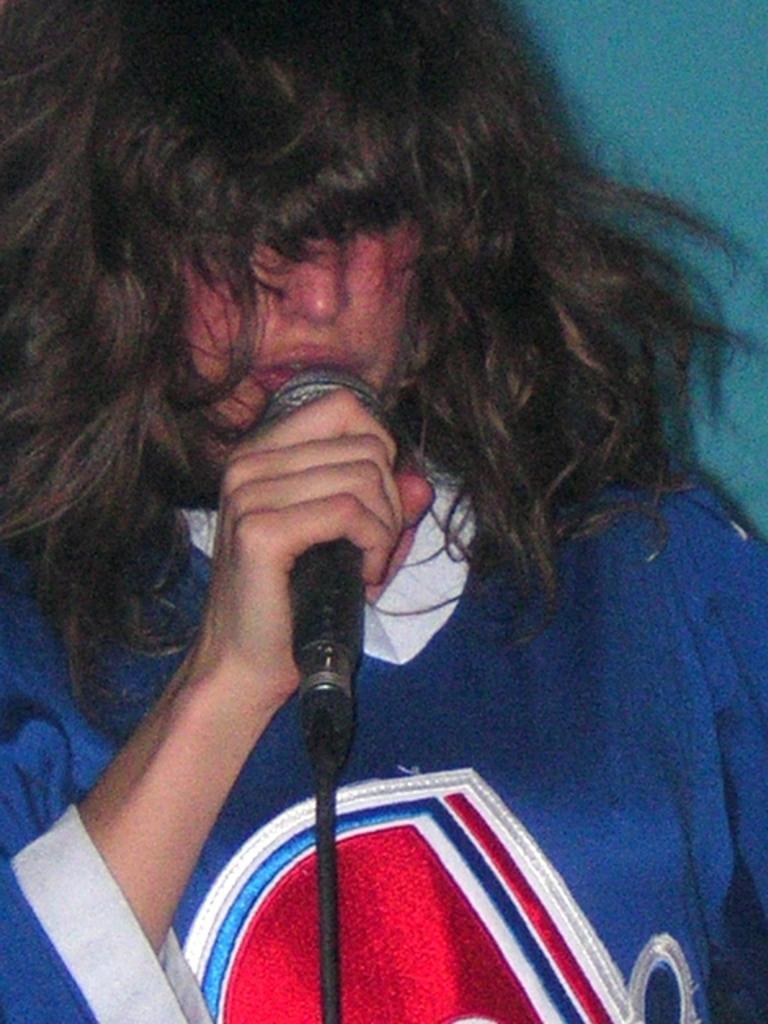Could you give a brief overview of what you see in this image? In the center we can see one person holding microphone. 